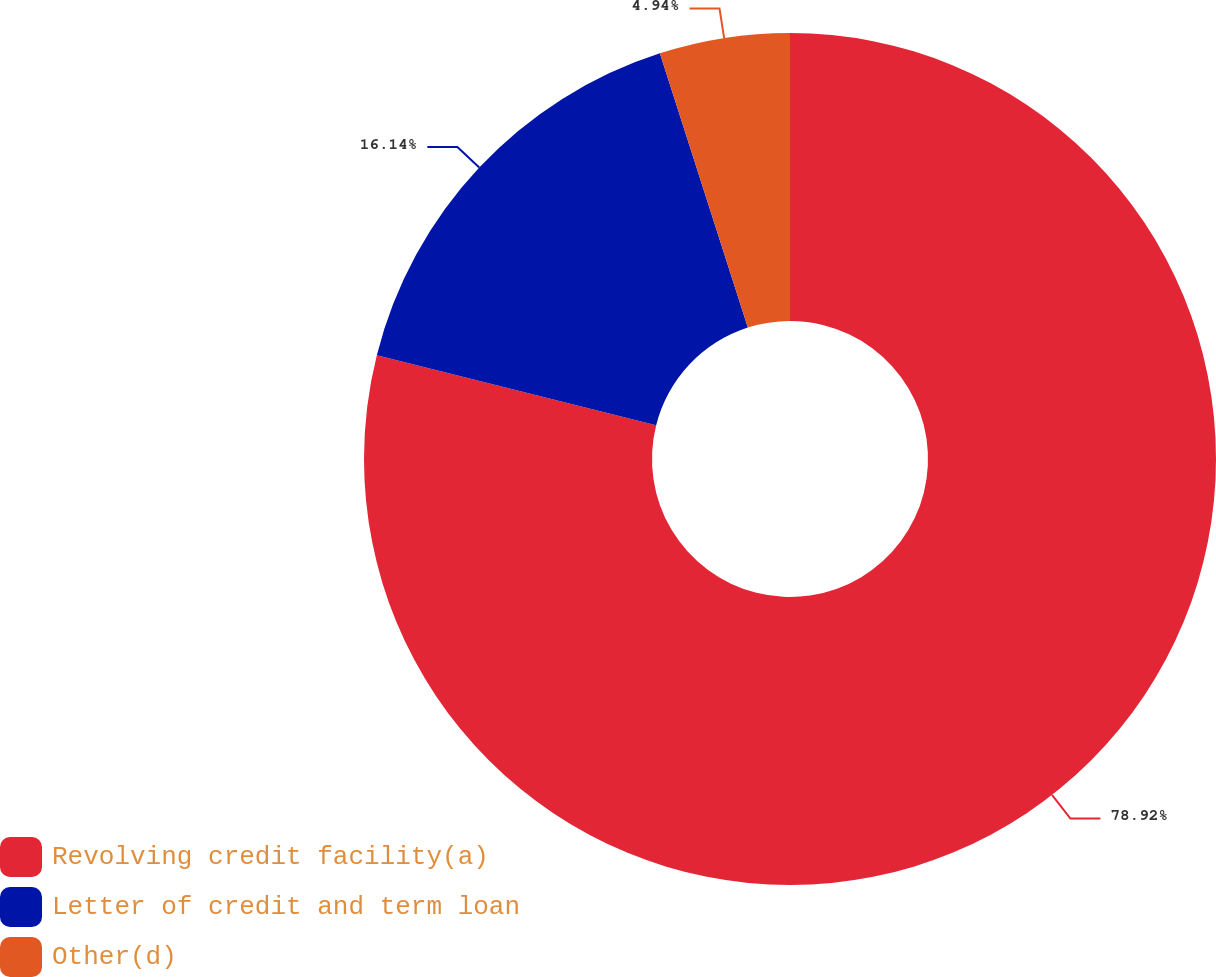Convert chart. <chart><loc_0><loc_0><loc_500><loc_500><pie_chart><fcel>Revolving credit facility(a)<fcel>Letter of credit and term loan<fcel>Other(d)<nl><fcel>78.91%<fcel>16.14%<fcel>4.94%<nl></chart> 